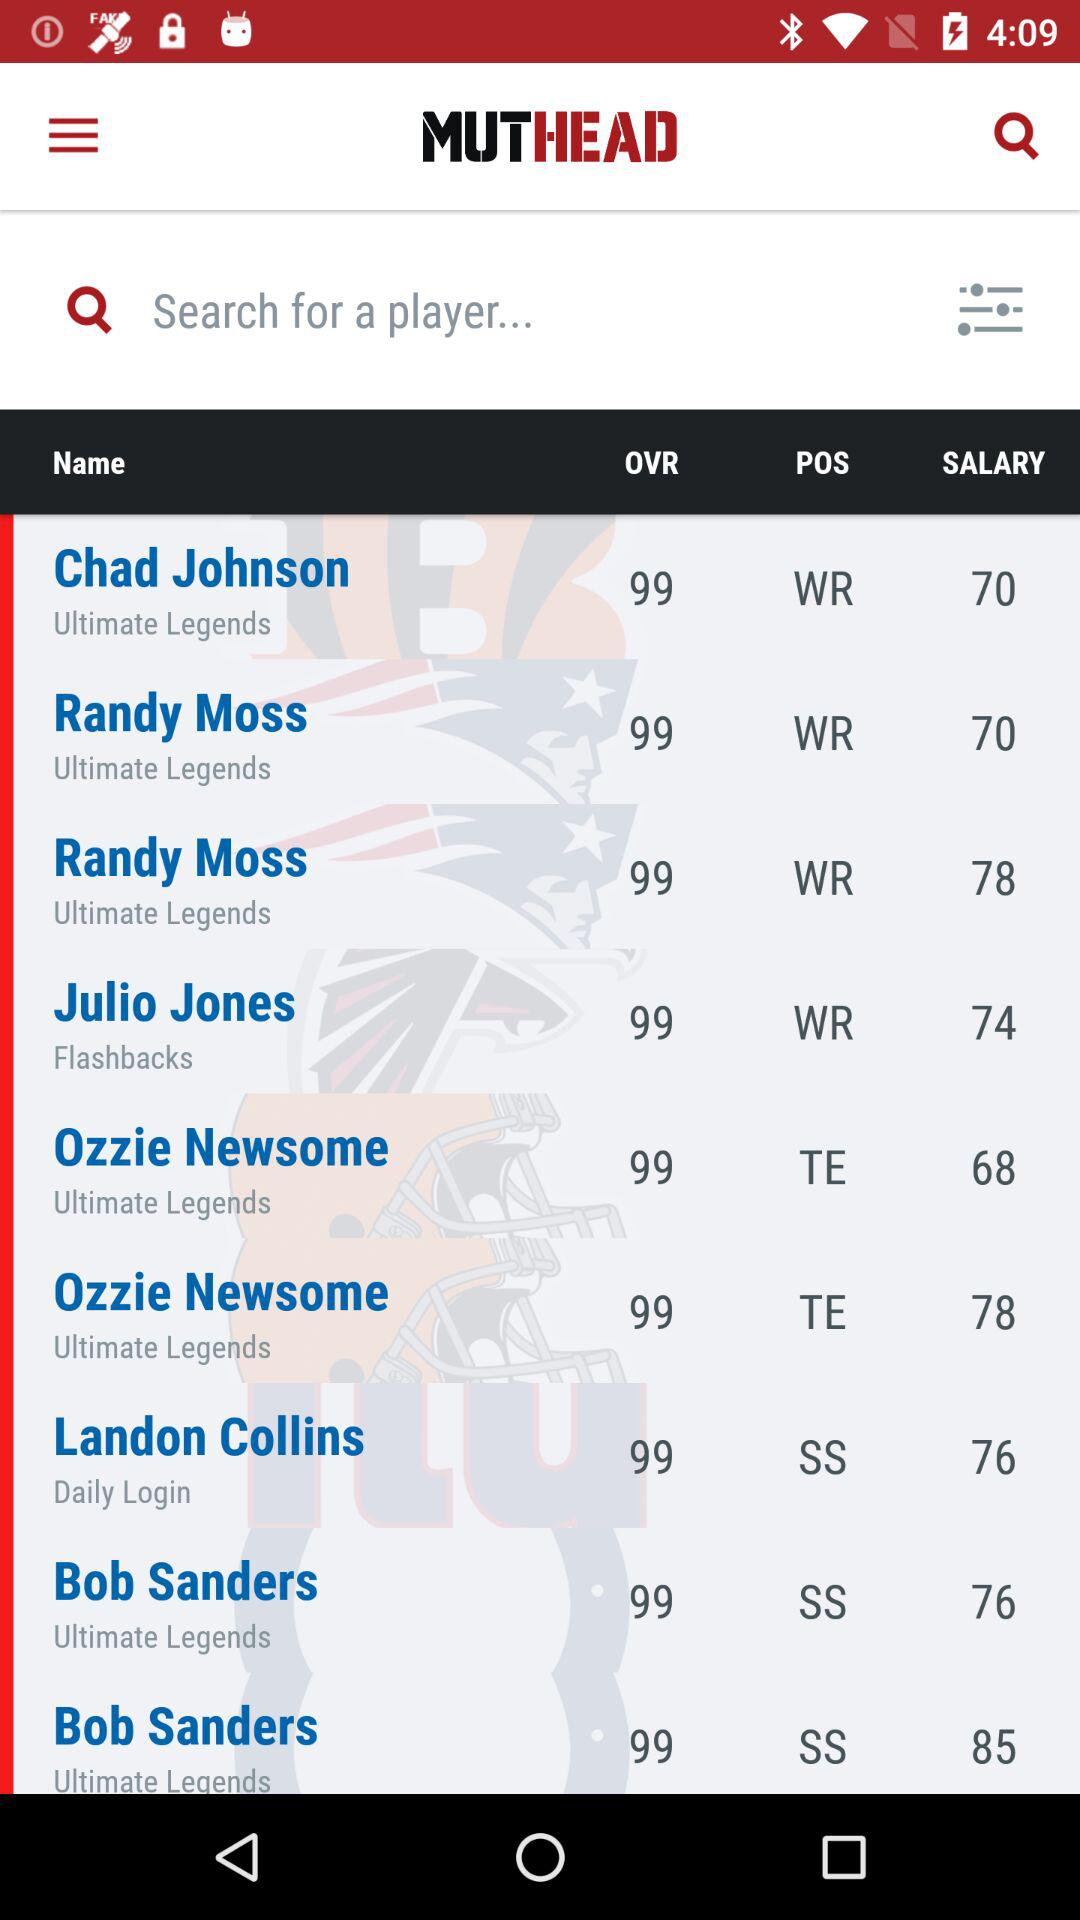What's the overall rating of Julio Jones? The overall rating is 99. 